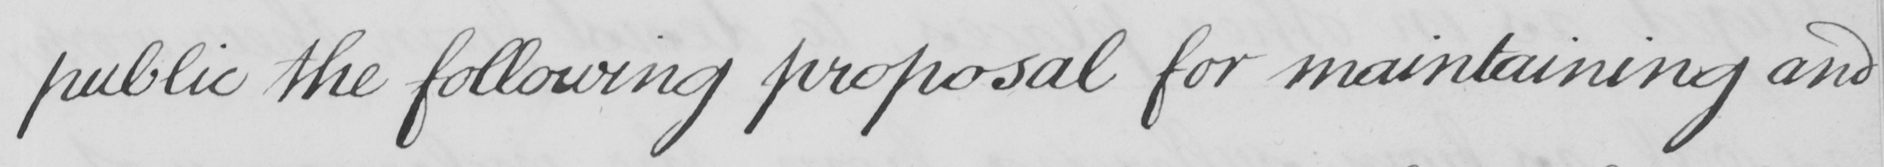Please transcribe the handwritten text in this image. public the following proposal for maintaining and 